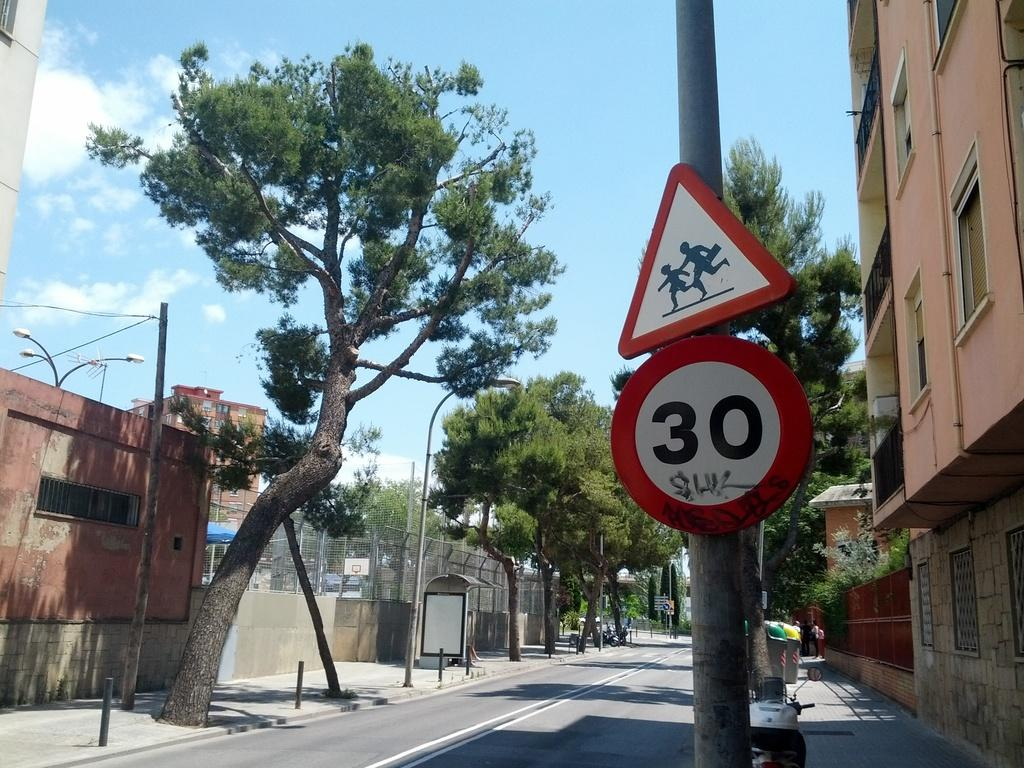<image>
Offer a succinct explanation of the picture presented. A street sign that says 30 and another that shows children running. 